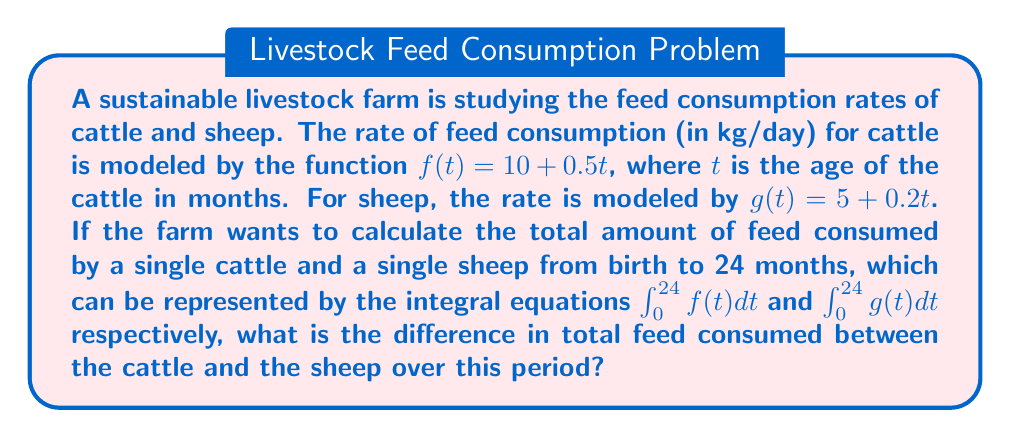Help me with this question. To solve this problem, we need to calculate the integrals for both cattle and sheep, then find the difference between them. Let's break it down step-by-step:

1. For cattle:
   $$\int_0^{24} f(t) dt = \int_0^{24} (10 + 0.5t) dt$$
   
   Integrating:
   $$= [10t + 0.25t^2]_0^{24}$$
   $$= (10 \cdot 24 + 0.25 \cdot 24^2) - (10 \cdot 0 + 0.25 \cdot 0^2)$$
   $$= 240 + 144 - 0 = 384$$

2. For sheep:
   $$\int_0^{24} g(t) dt = \int_0^{24} (5 + 0.2t) dt$$
   
   Integrating:
   $$= [5t + 0.1t^2]_0^{24}$$
   $$= (5 \cdot 24 + 0.1 \cdot 24^2) - (5 \cdot 0 + 0.1 \cdot 0^2)$$
   $$= 120 + 57.6 - 0 = 177.6$$

3. Calculate the difference:
   Cattle total - Sheep total = $384 - 177.6 = 206.4$

Therefore, the difference in total feed consumed between the cattle and the sheep over 24 months is 206.4 kg.
Answer: 206.4 kg 